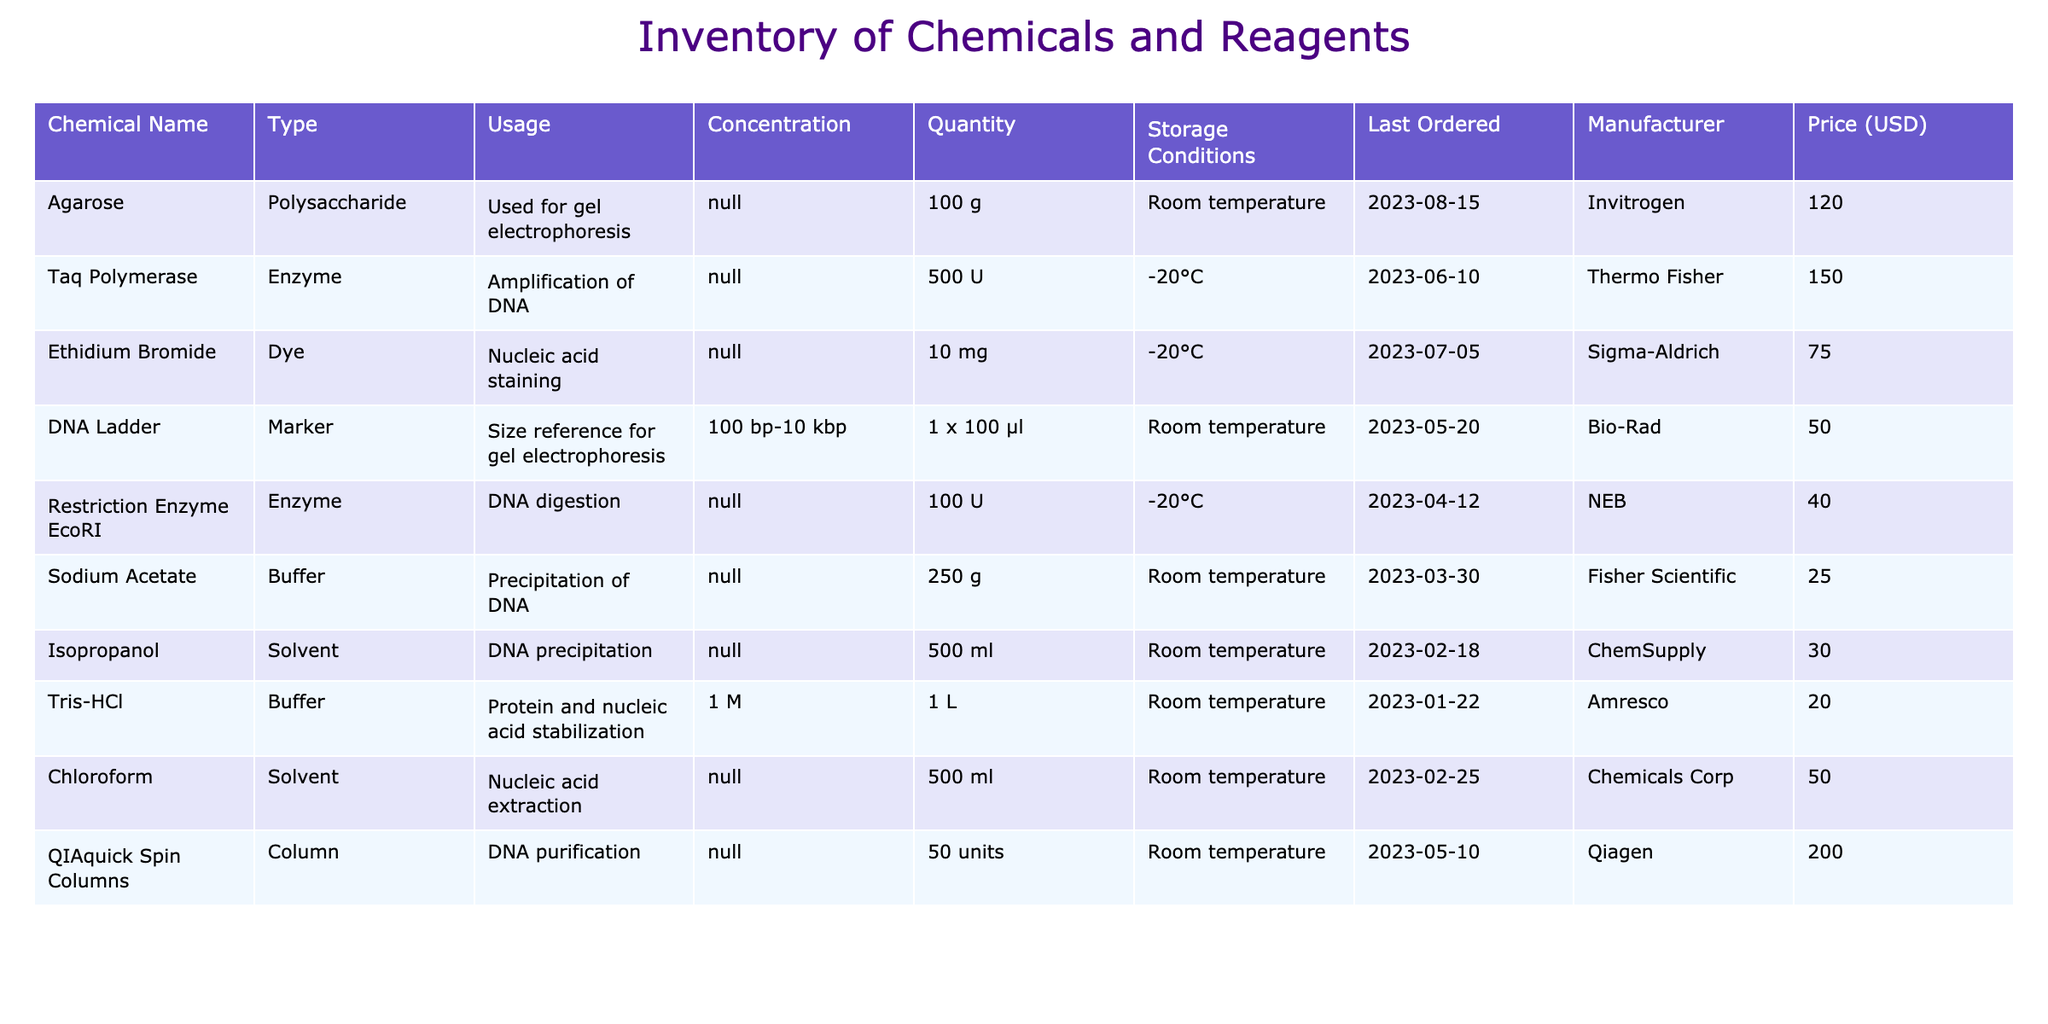What is the total quantity of solvents in the inventory? The total quantity of solvents can be found by summing the quantities of Isopropanol and Chloroform. Isopropanol has a quantity of 500 ml and Chloroform has a quantity of 500 ml. Therefore, the total is 500 ml + 500 ml = 1000 ml.
Answer: 1000 ml Which chemical was last ordered on June 10, 2023? Referring to the "Last Ordered" column, Taq Polymerase is the only chemical that has the date of June 10, 2023.
Answer: Taq Polymerase Is Ethidium Bromide stored at room temperature? The storage conditions for Ethidium Bromide indicate it is stored at -20°C, which is not room temperature.
Answer: No How many types of enzymes are listed in the inventory? In the "Type" column, the entries Taq Polymerase and Restriction Enzyme EcoRI are listed as enzymes. This counts to a total of 2 distinct enzyme types present in the inventory.
Answer: 2 What is the price difference between the most expensive and the least expensive reagents in the inventory? The most expensive reagent is QIAquick Spin Columns at 200.00 USD and the least expensive is Sodium Acetate at 25.00 USD. The price difference is calculated as 200.00 USD - 25.00 USD = 175.00 USD.
Answer: 175.00 USD What type of buffer is Tris-HCl, and what is its concentration? Tris-HCl is classified as a buffer in the "Type" column of the table, and its concentration is indicated as 1 M in the "Concentration" column.
Answer: Buffer, 1 M Which manufacturer provides the reagent with the highest quantity? Analyzing the "Quantity" column, Agarose has the highest quantity at 100 g. Its manufacturer, as listed, is Invitrogen.
Answer: Invitrogen Do we have any chemicals that are used for nucleic acid staining? Ethidium Bromide is specifically mentioned in the "Usage" column as a chemical used for nucleic acid staining.
Answer: Yes What is the total quantity of buffers listed in the inventory? By examining the "Type" column, there are two buffers: Tris-HCl and Sodium Acetate. Correspondingly, Tris-HCl has a quantity of 1 L and Sodium Acetate has a quantity of 250 g. However, because these are in different units, a total cannot be calculated directly without unit conversion. Therefore, we will keep them separately as their respective types and quantities.
Answer: 1 L and 250 g 